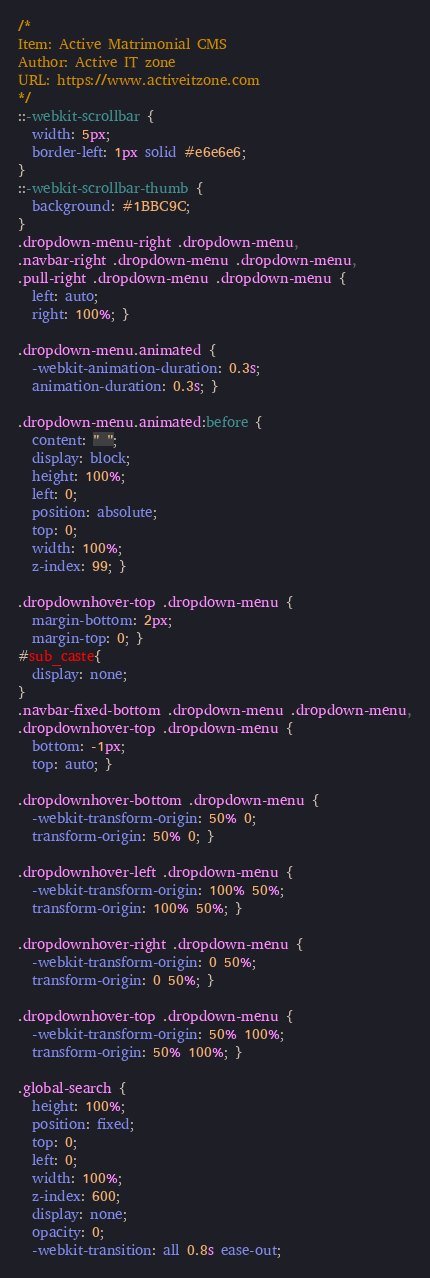<code> <loc_0><loc_0><loc_500><loc_500><_CSS_>/*
Item: Active Matrimonial CMS
Author: Active IT zone
URL: https://www.activeitzone.com
*/
::-webkit-scrollbar {
  width: 5px;
  border-left: 1px solid #e6e6e6;
}
::-webkit-scrollbar-thumb {
  background: #1BBC9C;
}
.dropdown-menu-right .dropdown-menu,
.navbar-right .dropdown-menu .dropdown-menu,
.pull-right .dropdown-menu .dropdown-menu {
  left: auto;
  right: 100%; }

.dropdown-menu.animated {
  -webkit-animation-duration: 0.3s;
  animation-duration: 0.3s; }

.dropdown-menu.animated:before {
  content: " ";
  display: block;
  height: 100%;
  left: 0;
  position: absolute;
  top: 0;
  width: 100%;
  z-index: 99; }

.dropdownhover-top .dropdown-menu {
  margin-bottom: 2px;
  margin-top: 0; }
#sub_caste{
  display: none;
}
.navbar-fixed-bottom .dropdown-menu .dropdown-menu,
.dropdownhover-top .dropdown-menu {
  bottom: -1px;
  top: auto; }

.dropdownhover-bottom .dropdown-menu {
  -webkit-transform-origin: 50% 0;
  transform-origin: 50% 0; }

.dropdownhover-left .dropdown-menu {
  -webkit-transform-origin: 100% 50%;
  transform-origin: 100% 50%; }

.dropdownhover-right .dropdown-menu {
  -webkit-transform-origin: 0 50%;
  transform-origin: 0 50%; }

.dropdownhover-top .dropdown-menu {
  -webkit-transform-origin: 50% 100%;
  transform-origin: 50% 100%; }

.global-search {
  height: 100%;
  position: fixed;
  top: 0;
  left: 0;
  width: 100%;
  z-index: 600;
  display: none;
  opacity: 0;
  -webkit-transition: all 0.8s ease-out;</code> 